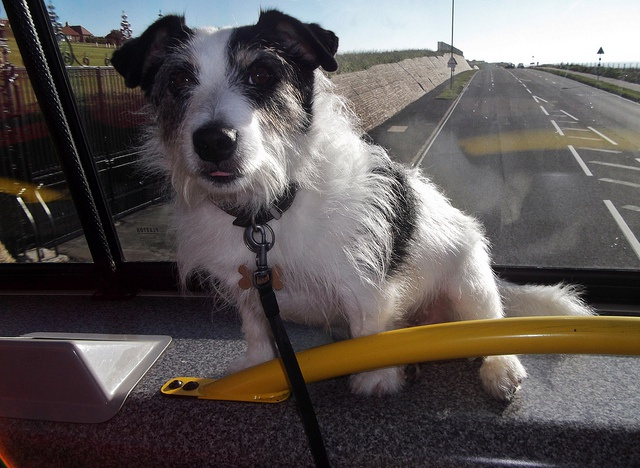Describe the objects in this image and their specific colors. I can see a dog in lightblue, gray, black, darkgray, and lightgray tones in this image. 